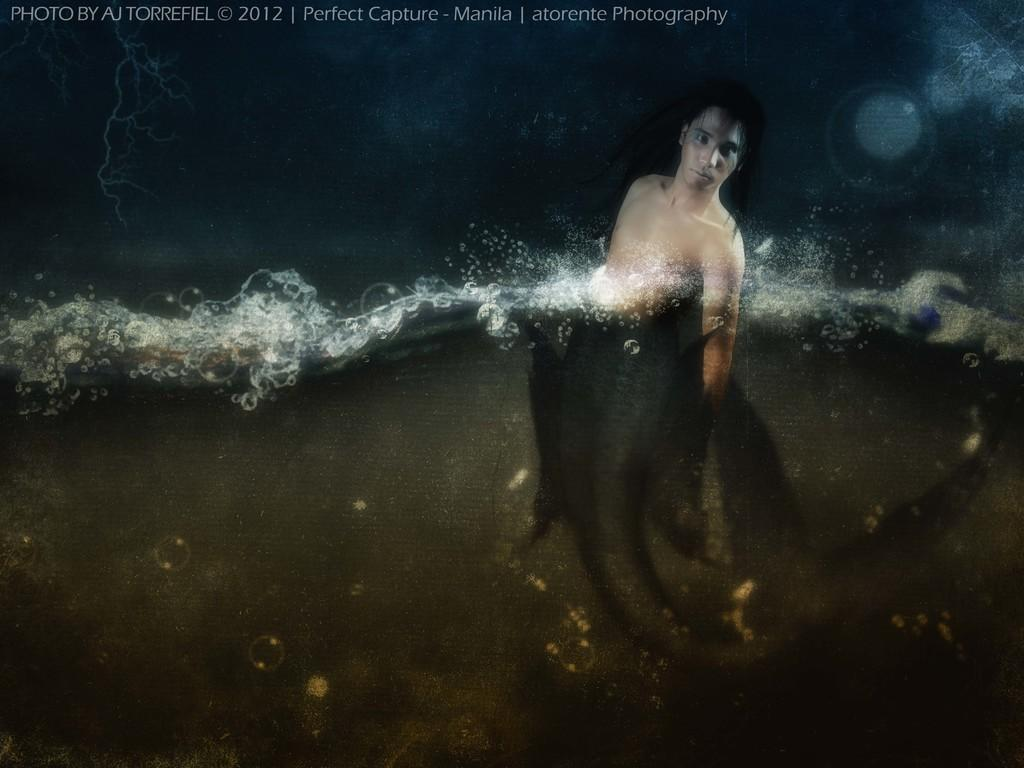What is the person in the image doing? The person is in the water. Can you describe anything else visible in the image? There is text visible at the top of the image. What substance is the person using to float in the water? There is no information about a substance being used to float in the image. Can you see the person's father in the image? There is no mention of a father or any other person in the image. 